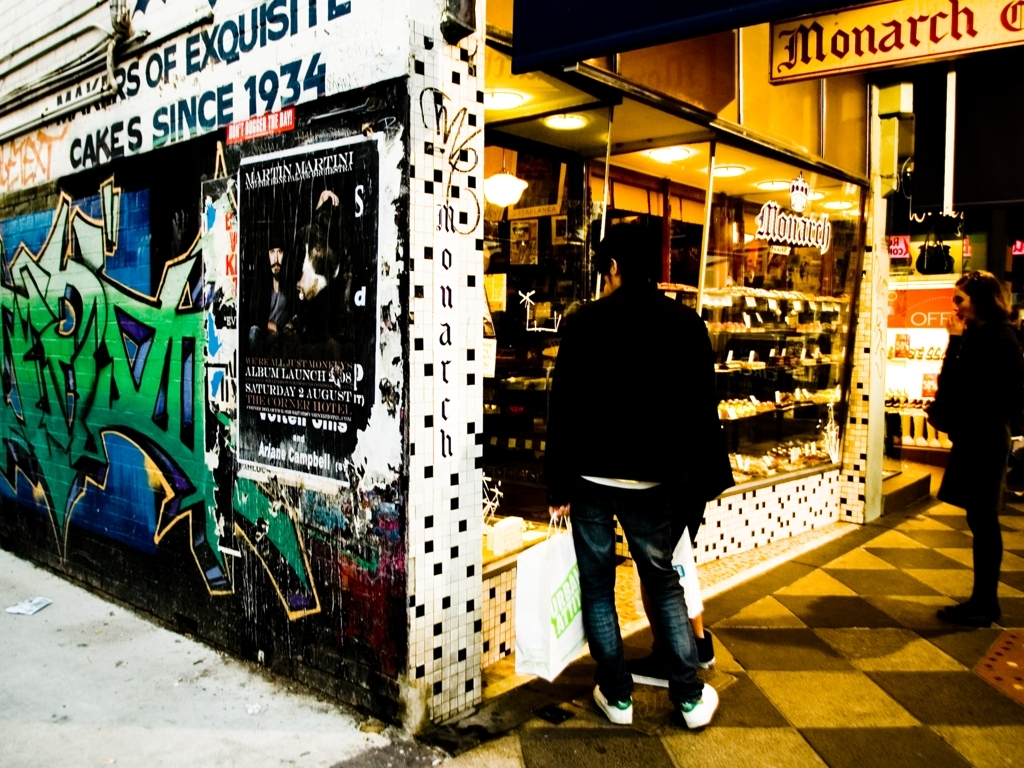Can you describe the atmosphere or mood that this image conveys? The image exudes an urban, somewhat eclectic vibe. The contrast between the vibrancy of the graffiti and the traditional-looking cake shop suggests a neighborhood rich in history yet pulsing with contemporary energy. The illuminated shop against the twilight setting adds a cozy, inviting element amidst the street's edginess. 